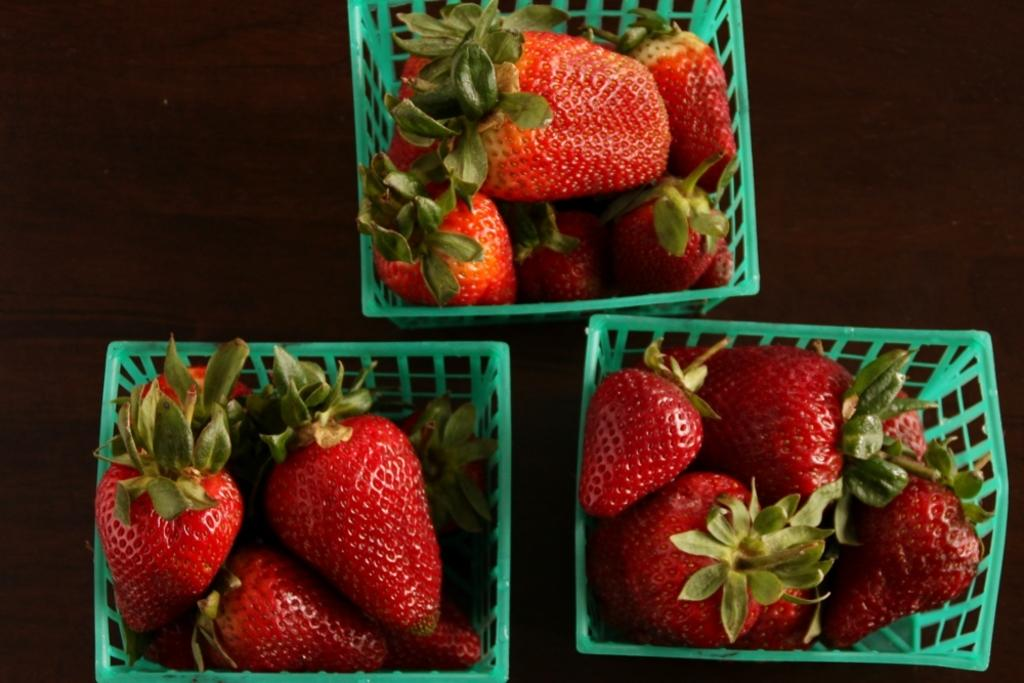What type of food items can be seen in the image? There are fruits in the image. How are the fruits arranged or contained in the image? The fruits are in green colored objects. What is the surface on which the objects are placed? The objects are placed on a wooden surface. What type of cloth is being used to cover the fruits in the image? There is no cloth present in the image; the fruits are in green colored objects. What type of business is being conducted in the image? There is no indication of a business in the image; it primarily features fruits in green colored objects on a wooden surface. 